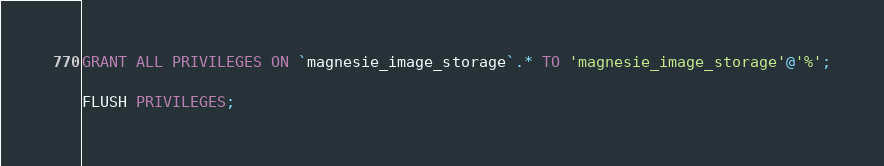<code> <loc_0><loc_0><loc_500><loc_500><_SQL_>
GRANT ALL PRIVILEGES ON `magnesie_image_storage`.* TO 'magnesie_image_storage'@'%';

FLUSH PRIVILEGES;
</code> 